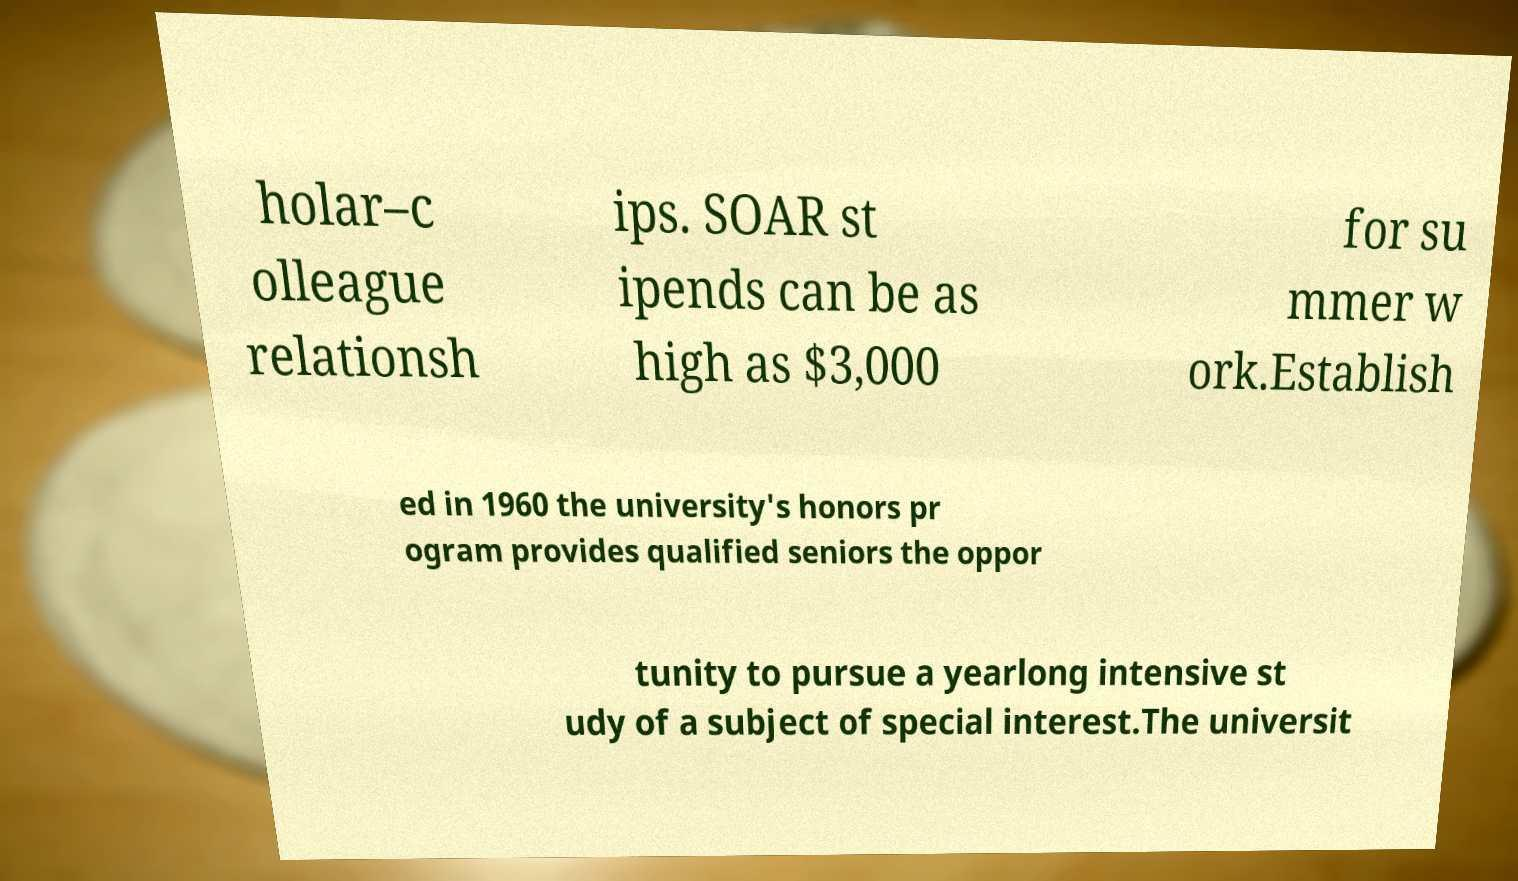For documentation purposes, I need the text within this image transcribed. Could you provide that? holar–c olleague relationsh ips. SOAR st ipends can be as high as $3,000 for su mmer w ork.Establish ed in 1960 the university's honors pr ogram provides qualified seniors the oppor tunity to pursue a yearlong intensive st udy of a subject of special interest.The universit 